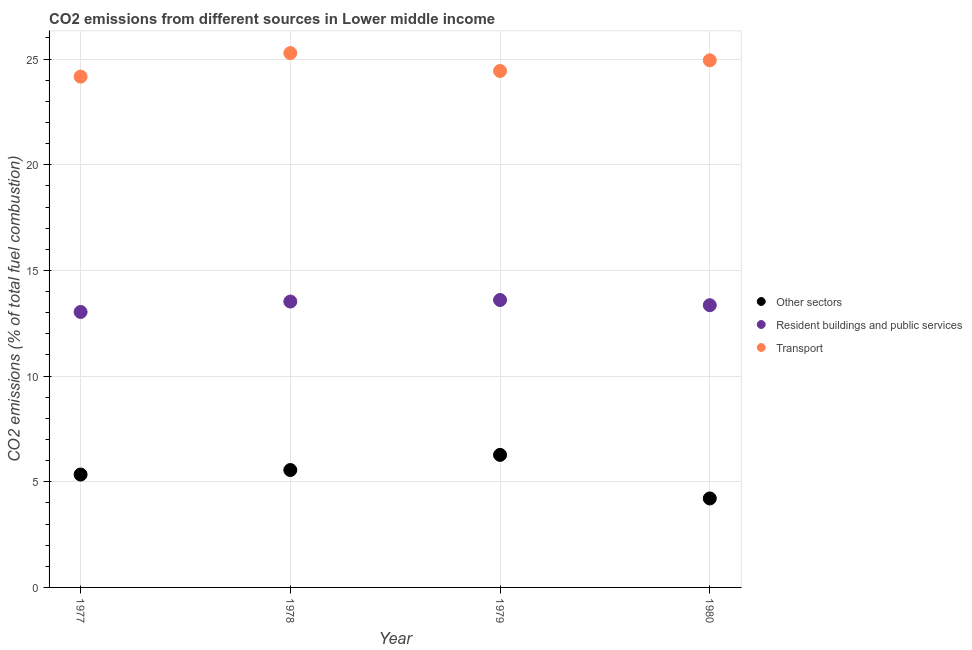Is the number of dotlines equal to the number of legend labels?
Keep it short and to the point. Yes. What is the percentage of co2 emissions from resident buildings and public services in 1980?
Provide a succinct answer. 13.35. Across all years, what is the maximum percentage of co2 emissions from other sectors?
Keep it short and to the point. 6.27. Across all years, what is the minimum percentage of co2 emissions from other sectors?
Keep it short and to the point. 4.21. In which year was the percentage of co2 emissions from other sectors maximum?
Give a very brief answer. 1979. In which year was the percentage of co2 emissions from other sectors minimum?
Keep it short and to the point. 1980. What is the total percentage of co2 emissions from resident buildings and public services in the graph?
Make the answer very short. 53.52. What is the difference between the percentage of co2 emissions from resident buildings and public services in 1977 and that in 1979?
Make the answer very short. -0.57. What is the difference between the percentage of co2 emissions from transport in 1979 and the percentage of co2 emissions from resident buildings and public services in 1980?
Make the answer very short. 11.08. What is the average percentage of co2 emissions from transport per year?
Ensure brevity in your answer.  24.71. In the year 1980, what is the difference between the percentage of co2 emissions from resident buildings and public services and percentage of co2 emissions from transport?
Keep it short and to the point. -11.59. In how many years, is the percentage of co2 emissions from resident buildings and public services greater than 5 %?
Ensure brevity in your answer.  4. What is the ratio of the percentage of co2 emissions from other sectors in 1978 to that in 1980?
Your answer should be very brief. 1.32. What is the difference between the highest and the second highest percentage of co2 emissions from other sectors?
Provide a short and direct response. 0.72. What is the difference between the highest and the lowest percentage of co2 emissions from transport?
Ensure brevity in your answer.  1.11. Is it the case that in every year, the sum of the percentage of co2 emissions from other sectors and percentage of co2 emissions from resident buildings and public services is greater than the percentage of co2 emissions from transport?
Make the answer very short. No. Does the percentage of co2 emissions from resident buildings and public services monotonically increase over the years?
Your answer should be compact. No. How many years are there in the graph?
Make the answer very short. 4. What is the difference between two consecutive major ticks on the Y-axis?
Give a very brief answer. 5. Are the values on the major ticks of Y-axis written in scientific E-notation?
Offer a terse response. No. Does the graph contain any zero values?
Ensure brevity in your answer.  No. What is the title of the graph?
Your response must be concise. CO2 emissions from different sources in Lower middle income. What is the label or title of the X-axis?
Provide a short and direct response. Year. What is the label or title of the Y-axis?
Offer a terse response. CO2 emissions (% of total fuel combustion). What is the CO2 emissions (% of total fuel combustion) of Other sectors in 1977?
Provide a succinct answer. 5.34. What is the CO2 emissions (% of total fuel combustion) of Resident buildings and public services in 1977?
Provide a succinct answer. 13.03. What is the CO2 emissions (% of total fuel combustion) of Transport in 1977?
Your answer should be compact. 24.17. What is the CO2 emissions (% of total fuel combustion) of Other sectors in 1978?
Your answer should be very brief. 5.56. What is the CO2 emissions (% of total fuel combustion) in Resident buildings and public services in 1978?
Provide a succinct answer. 13.53. What is the CO2 emissions (% of total fuel combustion) in Transport in 1978?
Offer a terse response. 25.28. What is the CO2 emissions (% of total fuel combustion) in Other sectors in 1979?
Your answer should be very brief. 6.27. What is the CO2 emissions (% of total fuel combustion) of Resident buildings and public services in 1979?
Provide a succinct answer. 13.6. What is the CO2 emissions (% of total fuel combustion) in Transport in 1979?
Ensure brevity in your answer.  24.44. What is the CO2 emissions (% of total fuel combustion) of Other sectors in 1980?
Your answer should be very brief. 4.21. What is the CO2 emissions (% of total fuel combustion) of Resident buildings and public services in 1980?
Your response must be concise. 13.35. What is the CO2 emissions (% of total fuel combustion) in Transport in 1980?
Keep it short and to the point. 24.94. Across all years, what is the maximum CO2 emissions (% of total fuel combustion) in Other sectors?
Provide a short and direct response. 6.27. Across all years, what is the maximum CO2 emissions (% of total fuel combustion) of Resident buildings and public services?
Offer a very short reply. 13.6. Across all years, what is the maximum CO2 emissions (% of total fuel combustion) of Transport?
Keep it short and to the point. 25.28. Across all years, what is the minimum CO2 emissions (% of total fuel combustion) of Other sectors?
Give a very brief answer. 4.21. Across all years, what is the minimum CO2 emissions (% of total fuel combustion) of Resident buildings and public services?
Ensure brevity in your answer.  13.03. Across all years, what is the minimum CO2 emissions (% of total fuel combustion) in Transport?
Your answer should be compact. 24.17. What is the total CO2 emissions (% of total fuel combustion) of Other sectors in the graph?
Give a very brief answer. 21.38. What is the total CO2 emissions (% of total fuel combustion) in Resident buildings and public services in the graph?
Give a very brief answer. 53.52. What is the total CO2 emissions (% of total fuel combustion) of Transport in the graph?
Provide a short and direct response. 98.83. What is the difference between the CO2 emissions (% of total fuel combustion) in Other sectors in 1977 and that in 1978?
Provide a succinct answer. -0.21. What is the difference between the CO2 emissions (% of total fuel combustion) of Resident buildings and public services in 1977 and that in 1978?
Your answer should be very brief. -0.49. What is the difference between the CO2 emissions (% of total fuel combustion) in Transport in 1977 and that in 1978?
Provide a short and direct response. -1.11. What is the difference between the CO2 emissions (% of total fuel combustion) of Other sectors in 1977 and that in 1979?
Provide a succinct answer. -0.93. What is the difference between the CO2 emissions (% of total fuel combustion) in Resident buildings and public services in 1977 and that in 1979?
Ensure brevity in your answer.  -0.57. What is the difference between the CO2 emissions (% of total fuel combustion) of Transport in 1977 and that in 1979?
Provide a short and direct response. -0.27. What is the difference between the CO2 emissions (% of total fuel combustion) in Other sectors in 1977 and that in 1980?
Provide a short and direct response. 1.13. What is the difference between the CO2 emissions (% of total fuel combustion) of Resident buildings and public services in 1977 and that in 1980?
Provide a short and direct response. -0.32. What is the difference between the CO2 emissions (% of total fuel combustion) of Transport in 1977 and that in 1980?
Provide a succinct answer. -0.77. What is the difference between the CO2 emissions (% of total fuel combustion) of Other sectors in 1978 and that in 1979?
Offer a very short reply. -0.72. What is the difference between the CO2 emissions (% of total fuel combustion) in Resident buildings and public services in 1978 and that in 1979?
Give a very brief answer. -0.07. What is the difference between the CO2 emissions (% of total fuel combustion) in Transport in 1978 and that in 1979?
Your answer should be very brief. 0.85. What is the difference between the CO2 emissions (% of total fuel combustion) of Other sectors in 1978 and that in 1980?
Make the answer very short. 1.34. What is the difference between the CO2 emissions (% of total fuel combustion) of Resident buildings and public services in 1978 and that in 1980?
Offer a terse response. 0.17. What is the difference between the CO2 emissions (% of total fuel combustion) of Transport in 1978 and that in 1980?
Provide a short and direct response. 0.34. What is the difference between the CO2 emissions (% of total fuel combustion) of Other sectors in 1979 and that in 1980?
Your answer should be compact. 2.06. What is the difference between the CO2 emissions (% of total fuel combustion) of Resident buildings and public services in 1979 and that in 1980?
Give a very brief answer. 0.25. What is the difference between the CO2 emissions (% of total fuel combustion) of Transport in 1979 and that in 1980?
Offer a very short reply. -0.5. What is the difference between the CO2 emissions (% of total fuel combustion) of Other sectors in 1977 and the CO2 emissions (% of total fuel combustion) of Resident buildings and public services in 1978?
Make the answer very short. -8.19. What is the difference between the CO2 emissions (% of total fuel combustion) in Other sectors in 1977 and the CO2 emissions (% of total fuel combustion) in Transport in 1978?
Make the answer very short. -19.94. What is the difference between the CO2 emissions (% of total fuel combustion) in Resident buildings and public services in 1977 and the CO2 emissions (% of total fuel combustion) in Transport in 1978?
Provide a succinct answer. -12.25. What is the difference between the CO2 emissions (% of total fuel combustion) of Other sectors in 1977 and the CO2 emissions (% of total fuel combustion) of Resident buildings and public services in 1979?
Your response must be concise. -8.26. What is the difference between the CO2 emissions (% of total fuel combustion) in Other sectors in 1977 and the CO2 emissions (% of total fuel combustion) in Transport in 1979?
Offer a terse response. -19.09. What is the difference between the CO2 emissions (% of total fuel combustion) of Resident buildings and public services in 1977 and the CO2 emissions (% of total fuel combustion) of Transport in 1979?
Provide a short and direct response. -11.4. What is the difference between the CO2 emissions (% of total fuel combustion) in Other sectors in 1977 and the CO2 emissions (% of total fuel combustion) in Resident buildings and public services in 1980?
Make the answer very short. -8.01. What is the difference between the CO2 emissions (% of total fuel combustion) of Other sectors in 1977 and the CO2 emissions (% of total fuel combustion) of Transport in 1980?
Provide a short and direct response. -19.6. What is the difference between the CO2 emissions (% of total fuel combustion) of Resident buildings and public services in 1977 and the CO2 emissions (% of total fuel combustion) of Transport in 1980?
Offer a terse response. -11.91. What is the difference between the CO2 emissions (% of total fuel combustion) of Other sectors in 1978 and the CO2 emissions (% of total fuel combustion) of Resident buildings and public services in 1979?
Offer a terse response. -8.04. What is the difference between the CO2 emissions (% of total fuel combustion) in Other sectors in 1978 and the CO2 emissions (% of total fuel combustion) in Transport in 1979?
Provide a succinct answer. -18.88. What is the difference between the CO2 emissions (% of total fuel combustion) in Resident buildings and public services in 1978 and the CO2 emissions (% of total fuel combustion) in Transport in 1979?
Keep it short and to the point. -10.91. What is the difference between the CO2 emissions (% of total fuel combustion) of Other sectors in 1978 and the CO2 emissions (% of total fuel combustion) of Resident buildings and public services in 1980?
Make the answer very short. -7.8. What is the difference between the CO2 emissions (% of total fuel combustion) of Other sectors in 1978 and the CO2 emissions (% of total fuel combustion) of Transport in 1980?
Provide a succinct answer. -19.39. What is the difference between the CO2 emissions (% of total fuel combustion) in Resident buildings and public services in 1978 and the CO2 emissions (% of total fuel combustion) in Transport in 1980?
Your answer should be very brief. -11.41. What is the difference between the CO2 emissions (% of total fuel combustion) in Other sectors in 1979 and the CO2 emissions (% of total fuel combustion) in Resident buildings and public services in 1980?
Your response must be concise. -7.08. What is the difference between the CO2 emissions (% of total fuel combustion) in Other sectors in 1979 and the CO2 emissions (% of total fuel combustion) in Transport in 1980?
Provide a succinct answer. -18.67. What is the difference between the CO2 emissions (% of total fuel combustion) in Resident buildings and public services in 1979 and the CO2 emissions (% of total fuel combustion) in Transport in 1980?
Your response must be concise. -11.34. What is the average CO2 emissions (% of total fuel combustion) of Other sectors per year?
Offer a terse response. 5.34. What is the average CO2 emissions (% of total fuel combustion) of Resident buildings and public services per year?
Offer a very short reply. 13.38. What is the average CO2 emissions (% of total fuel combustion) in Transport per year?
Your answer should be very brief. 24.71. In the year 1977, what is the difference between the CO2 emissions (% of total fuel combustion) of Other sectors and CO2 emissions (% of total fuel combustion) of Resident buildings and public services?
Offer a terse response. -7.69. In the year 1977, what is the difference between the CO2 emissions (% of total fuel combustion) in Other sectors and CO2 emissions (% of total fuel combustion) in Transport?
Your answer should be very brief. -18.83. In the year 1977, what is the difference between the CO2 emissions (% of total fuel combustion) of Resident buildings and public services and CO2 emissions (% of total fuel combustion) of Transport?
Your answer should be compact. -11.14. In the year 1978, what is the difference between the CO2 emissions (% of total fuel combustion) in Other sectors and CO2 emissions (% of total fuel combustion) in Resident buildings and public services?
Provide a succinct answer. -7.97. In the year 1978, what is the difference between the CO2 emissions (% of total fuel combustion) of Other sectors and CO2 emissions (% of total fuel combustion) of Transport?
Provide a short and direct response. -19.73. In the year 1978, what is the difference between the CO2 emissions (% of total fuel combustion) in Resident buildings and public services and CO2 emissions (% of total fuel combustion) in Transport?
Your answer should be very brief. -11.76. In the year 1979, what is the difference between the CO2 emissions (% of total fuel combustion) in Other sectors and CO2 emissions (% of total fuel combustion) in Resident buildings and public services?
Keep it short and to the point. -7.33. In the year 1979, what is the difference between the CO2 emissions (% of total fuel combustion) in Other sectors and CO2 emissions (% of total fuel combustion) in Transport?
Keep it short and to the point. -18.17. In the year 1979, what is the difference between the CO2 emissions (% of total fuel combustion) of Resident buildings and public services and CO2 emissions (% of total fuel combustion) of Transport?
Provide a short and direct response. -10.84. In the year 1980, what is the difference between the CO2 emissions (% of total fuel combustion) in Other sectors and CO2 emissions (% of total fuel combustion) in Resident buildings and public services?
Make the answer very short. -9.14. In the year 1980, what is the difference between the CO2 emissions (% of total fuel combustion) of Other sectors and CO2 emissions (% of total fuel combustion) of Transport?
Keep it short and to the point. -20.73. In the year 1980, what is the difference between the CO2 emissions (% of total fuel combustion) in Resident buildings and public services and CO2 emissions (% of total fuel combustion) in Transport?
Your answer should be compact. -11.59. What is the ratio of the CO2 emissions (% of total fuel combustion) of Other sectors in 1977 to that in 1978?
Offer a terse response. 0.96. What is the ratio of the CO2 emissions (% of total fuel combustion) in Resident buildings and public services in 1977 to that in 1978?
Keep it short and to the point. 0.96. What is the ratio of the CO2 emissions (% of total fuel combustion) of Transport in 1977 to that in 1978?
Offer a very short reply. 0.96. What is the ratio of the CO2 emissions (% of total fuel combustion) of Other sectors in 1977 to that in 1979?
Offer a very short reply. 0.85. What is the ratio of the CO2 emissions (% of total fuel combustion) in Resident buildings and public services in 1977 to that in 1979?
Your answer should be compact. 0.96. What is the ratio of the CO2 emissions (% of total fuel combustion) of Transport in 1977 to that in 1979?
Your answer should be very brief. 0.99. What is the ratio of the CO2 emissions (% of total fuel combustion) in Other sectors in 1977 to that in 1980?
Your answer should be compact. 1.27. What is the ratio of the CO2 emissions (% of total fuel combustion) of Resident buildings and public services in 1977 to that in 1980?
Your response must be concise. 0.98. What is the ratio of the CO2 emissions (% of total fuel combustion) in Other sectors in 1978 to that in 1979?
Make the answer very short. 0.89. What is the ratio of the CO2 emissions (% of total fuel combustion) in Resident buildings and public services in 1978 to that in 1979?
Make the answer very short. 0.99. What is the ratio of the CO2 emissions (% of total fuel combustion) in Transport in 1978 to that in 1979?
Provide a short and direct response. 1.03. What is the ratio of the CO2 emissions (% of total fuel combustion) in Other sectors in 1978 to that in 1980?
Your response must be concise. 1.32. What is the ratio of the CO2 emissions (% of total fuel combustion) in Resident buildings and public services in 1978 to that in 1980?
Keep it short and to the point. 1.01. What is the ratio of the CO2 emissions (% of total fuel combustion) in Transport in 1978 to that in 1980?
Offer a terse response. 1.01. What is the ratio of the CO2 emissions (% of total fuel combustion) of Other sectors in 1979 to that in 1980?
Keep it short and to the point. 1.49. What is the ratio of the CO2 emissions (% of total fuel combustion) in Resident buildings and public services in 1979 to that in 1980?
Offer a terse response. 1.02. What is the ratio of the CO2 emissions (% of total fuel combustion) in Transport in 1979 to that in 1980?
Give a very brief answer. 0.98. What is the difference between the highest and the second highest CO2 emissions (% of total fuel combustion) in Other sectors?
Your answer should be very brief. 0.72. What is the difference between the highest and the second highest CO2 emissions (% of total fuel combustion) in Resident buildings and public services?
Keep it short and to the point. 0.07. What is the difference between the highest and the second highest CO2 emissions (% of total fuel combustion) in Transport?
Provide a short and direct response. 0.34. What is the difference between the highest and the lowest CO2 emissions (% of total fuel combustion) of Other sectors?
Your response must be concise. 2.06. What is the difference between the highest and the lowest CO2 emissions (% of total fuel combustion) in Resident buildings and public services?
Your answer should be compact. 0.57. What is the difference between the highest and the lowest CO2 emissions (% of total fuel combustion) of Transport?
Provide a succinct answer. 1.11. 